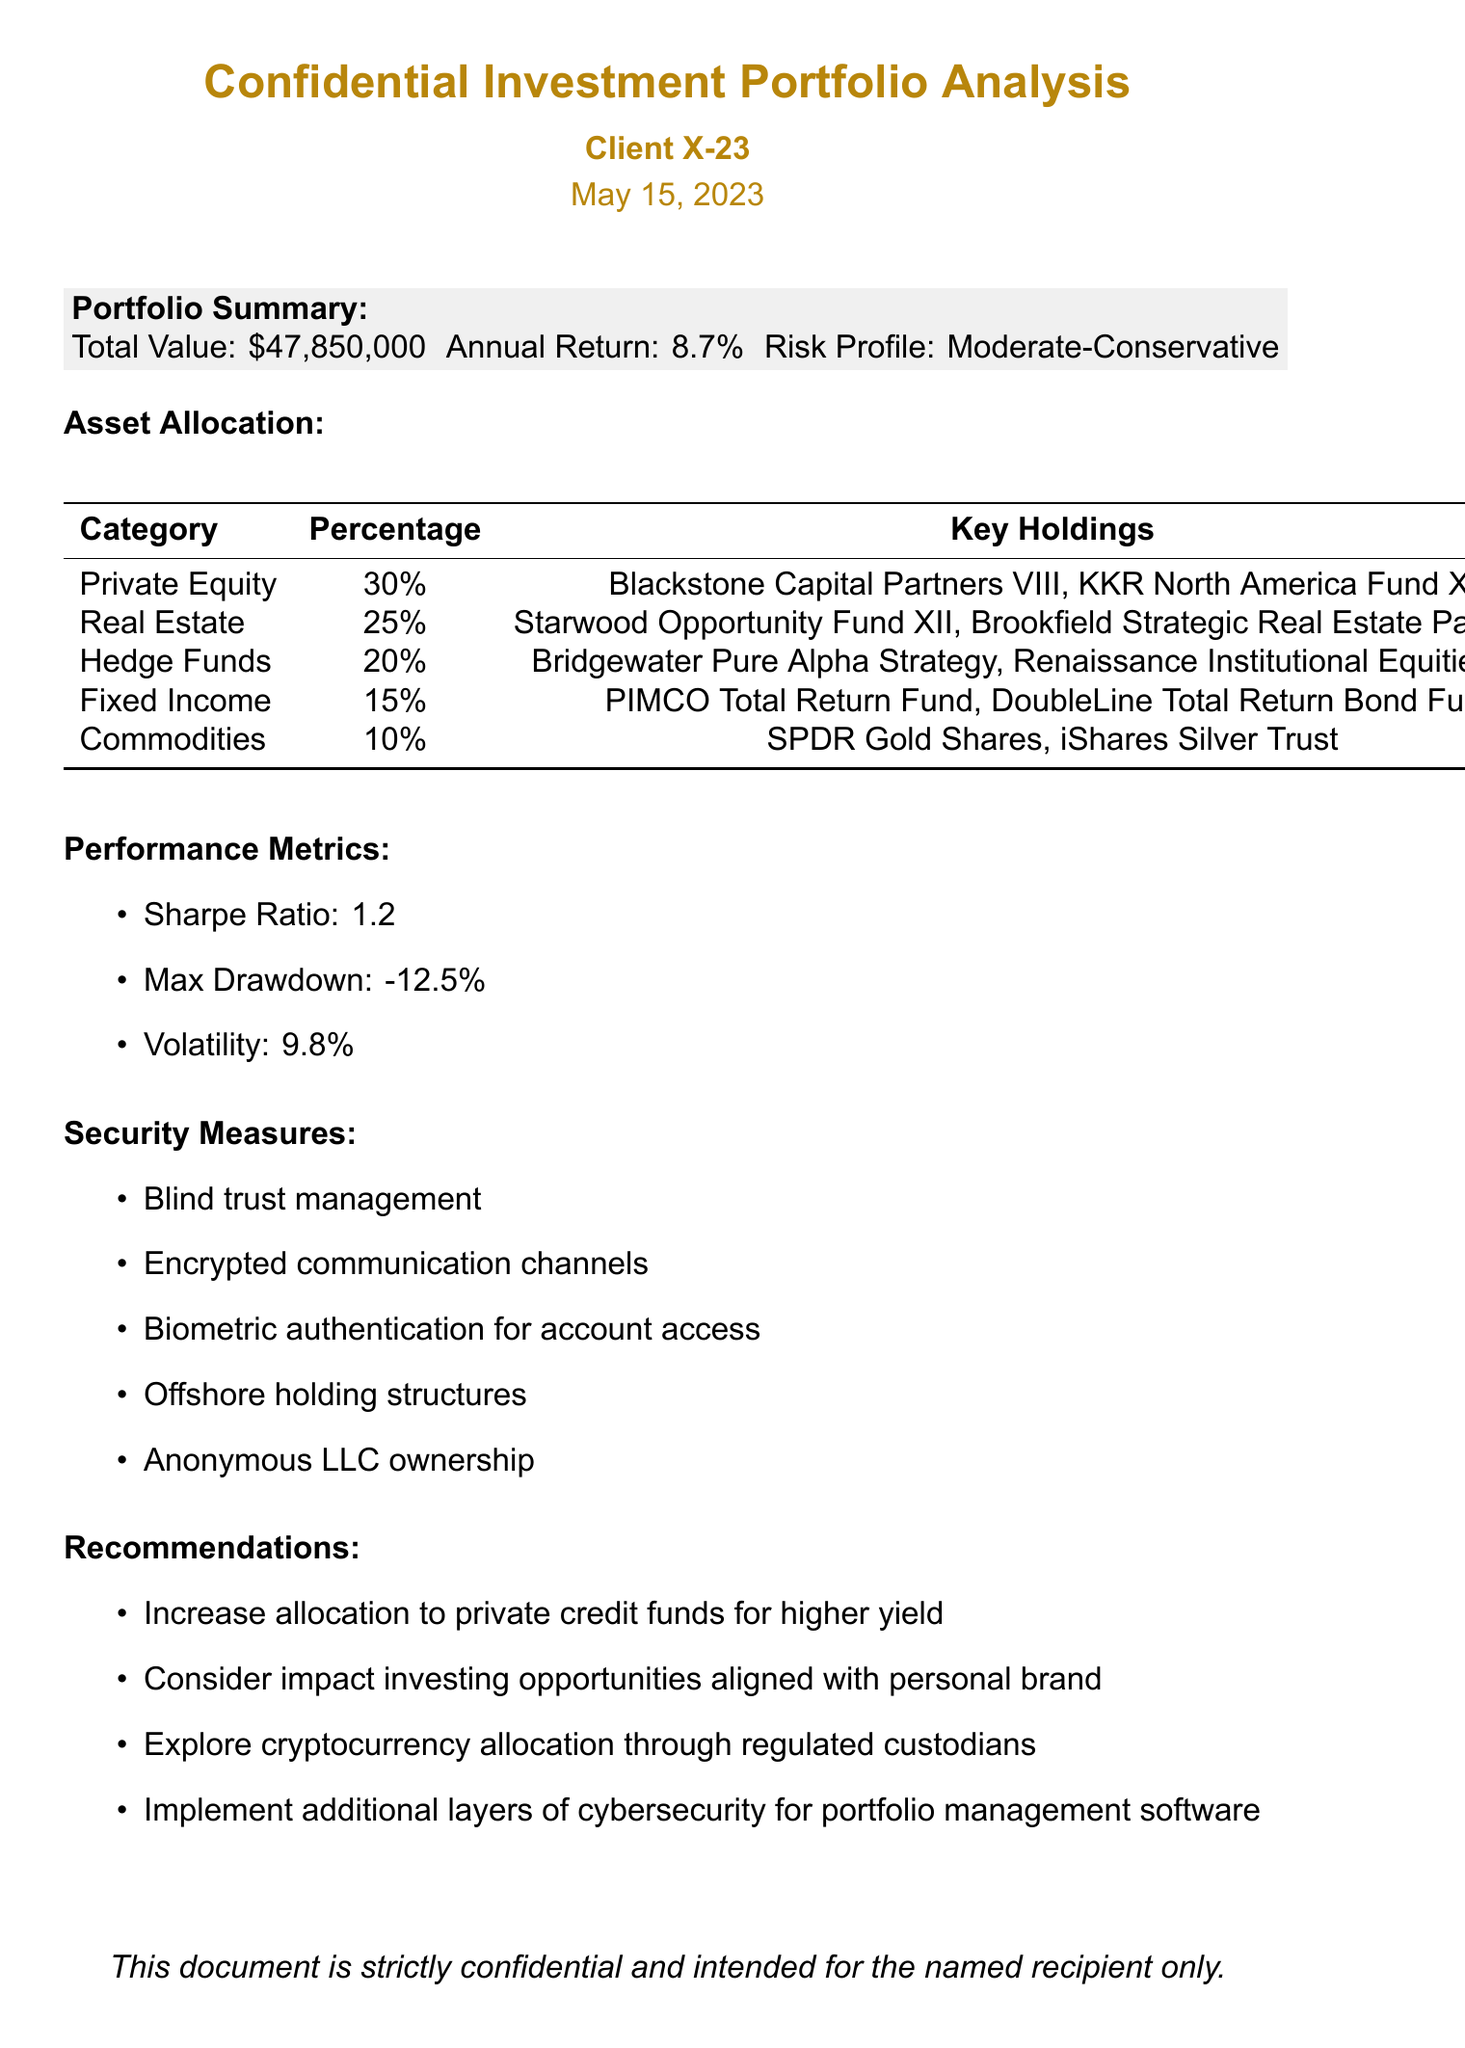What is the total value of the portfolio? The total value is clearly stated in the portfolio summary section of the document as $47,850,000.
Answer: $47,850,000 What is the annual return percentage? The annual return is mentioned in the portfolio summary, specifically noting it is 8.7%.
Answer: 8.7% What is the risk profile of the investment portfolio? The risk profile is found in the portfolio summary and is categorized as Moderate-Conservative.
Answer: Moderate-Conservative Which category has the highest allocation percentage? The asset allocation table shows that Private Equity has the highest percentage at 30%.
Answer: Private Equity What is the Sharpe Ratio provided in the performance metrics? The performance metrics section includes the Sharpe Ratio, which is stated as 1.2.
Answer: 1.2 What security measure involves biometric technology? Among the security measures, biometric authentication for account access specifically involves biometric technology.
Answer: Biometric authentication How does the document recommend increasing yield? The recommendations suggest increasing allocation to private credit funds for higher yield.
Answer: Private credit funds Which category comprises 10% of the asset allocation? The asset allocation table indicates that Commodities comprise 10% of the portfolio.
Answer: Commodities What is the maximum drawdown percentage reported? The performance metrics section includes the maximum drawdown, reported as -12.5%.
Answer: -12.5% What investment area does the document suggest exploring through regulated custodians? The recommendations section advises exploring cryptocurrency allocation through regulated custodians.
Answer: Cryptocurrency 